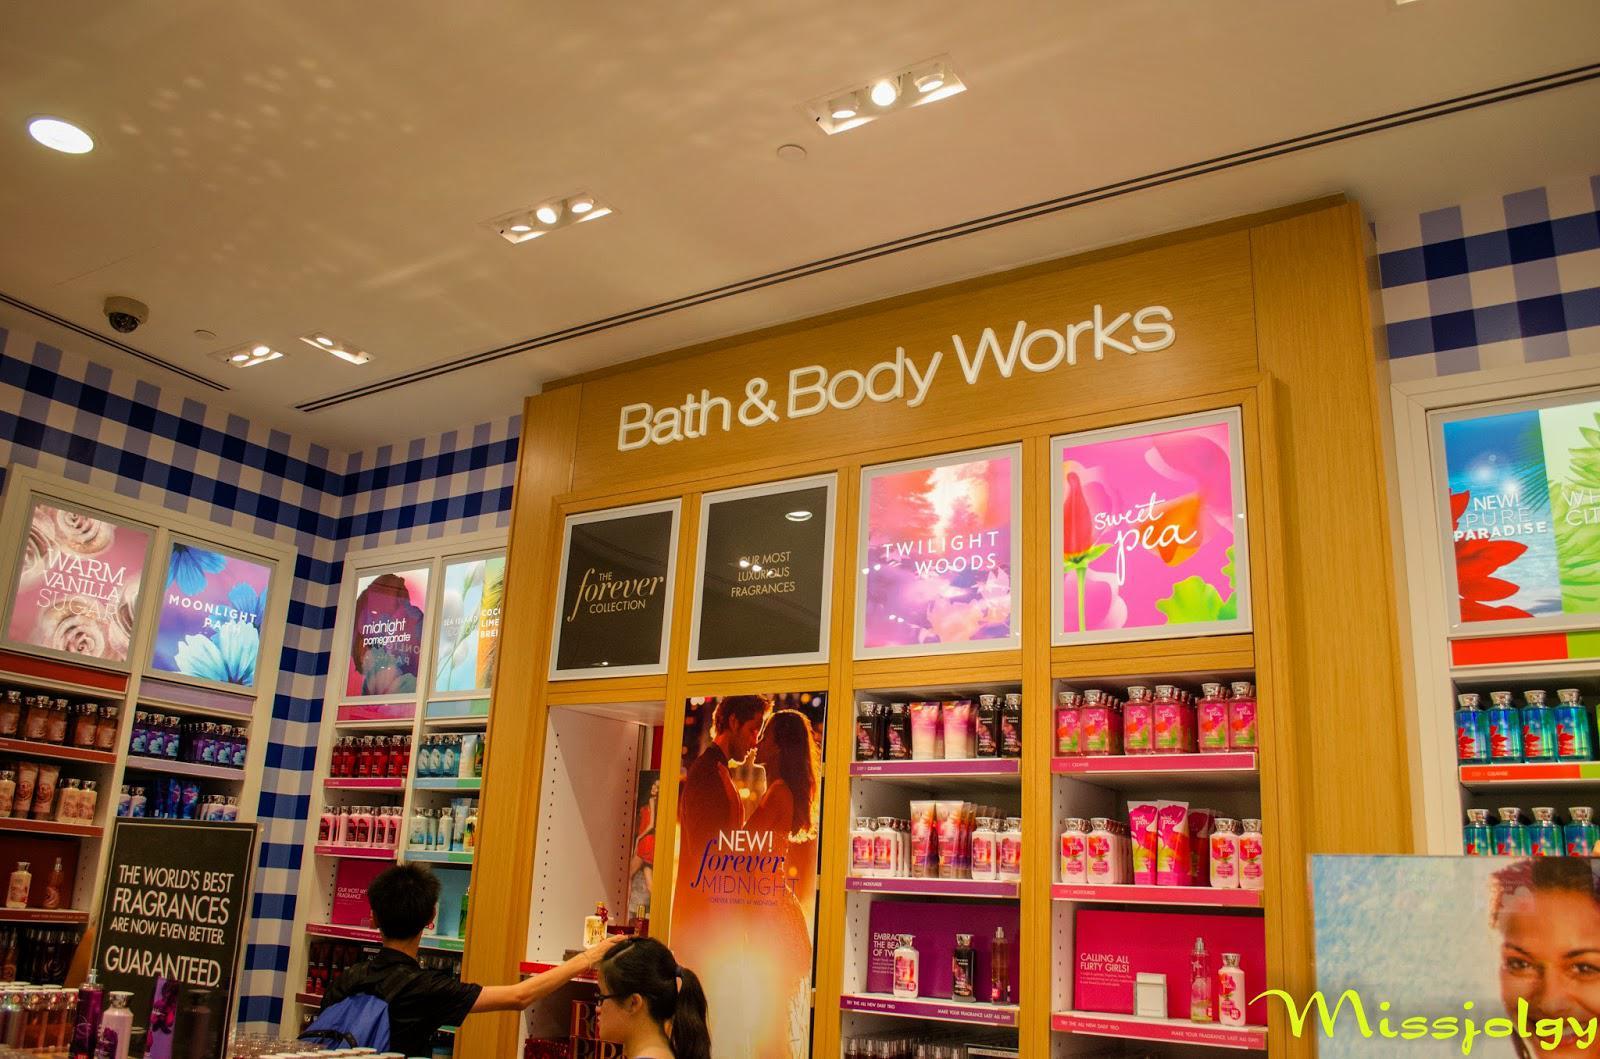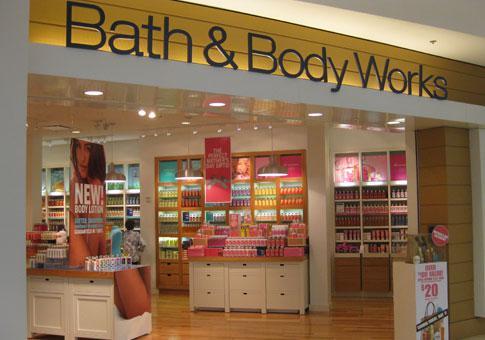The first image is the image on the left, the second image is the image on the right. Evaluate the accuracy of this statement regarding the images: "There are at least two people in one of the iamges.". Is it true? Answer yes or no. Yes. 